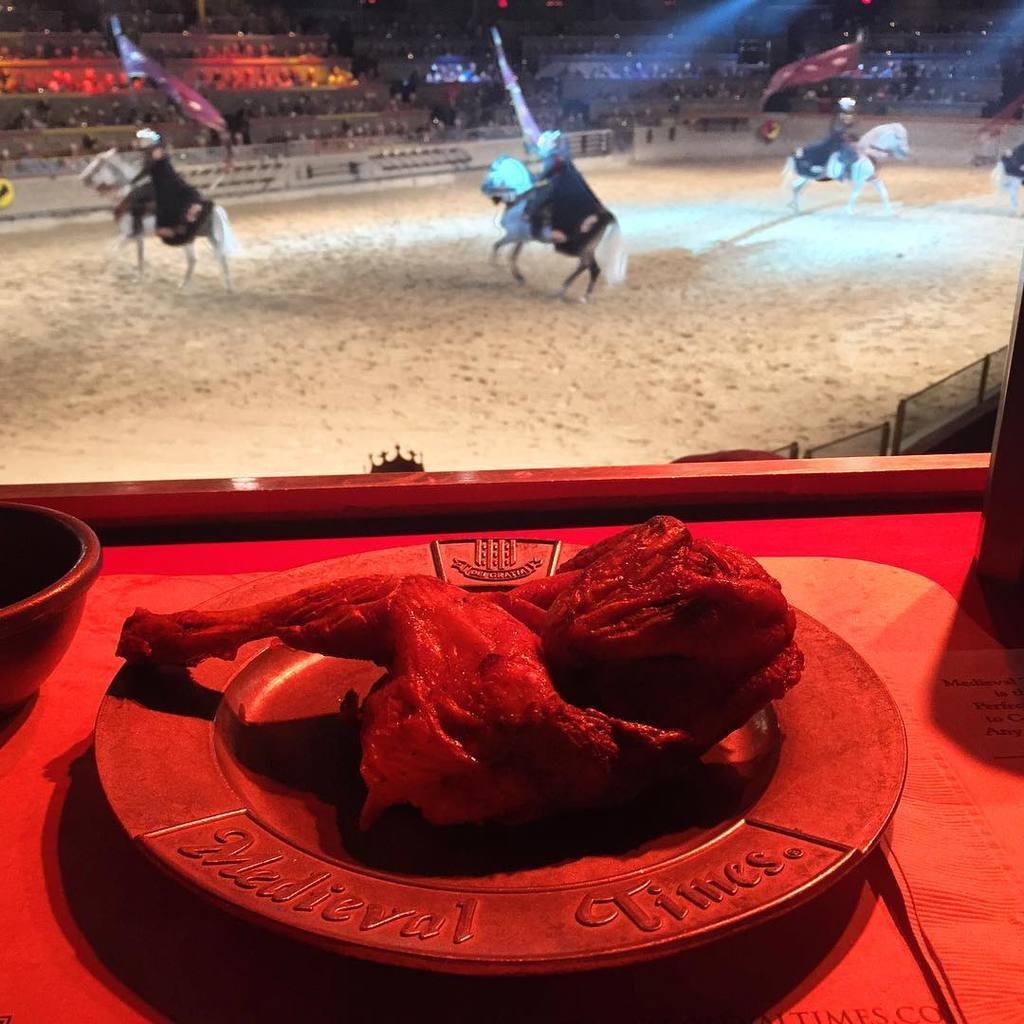Please provide a concise description of this image. In this image I can see a red colored surface and on the red colored surface I can see a plate and on which I can see the meat and I can see a bowl on the surface. In the background I can see the sand and few persons sitting on horses which are white in color are standing on the ground, the persons are holding flags in their hands and I can see the stadium and few persons sitting in the stadium in the background. 